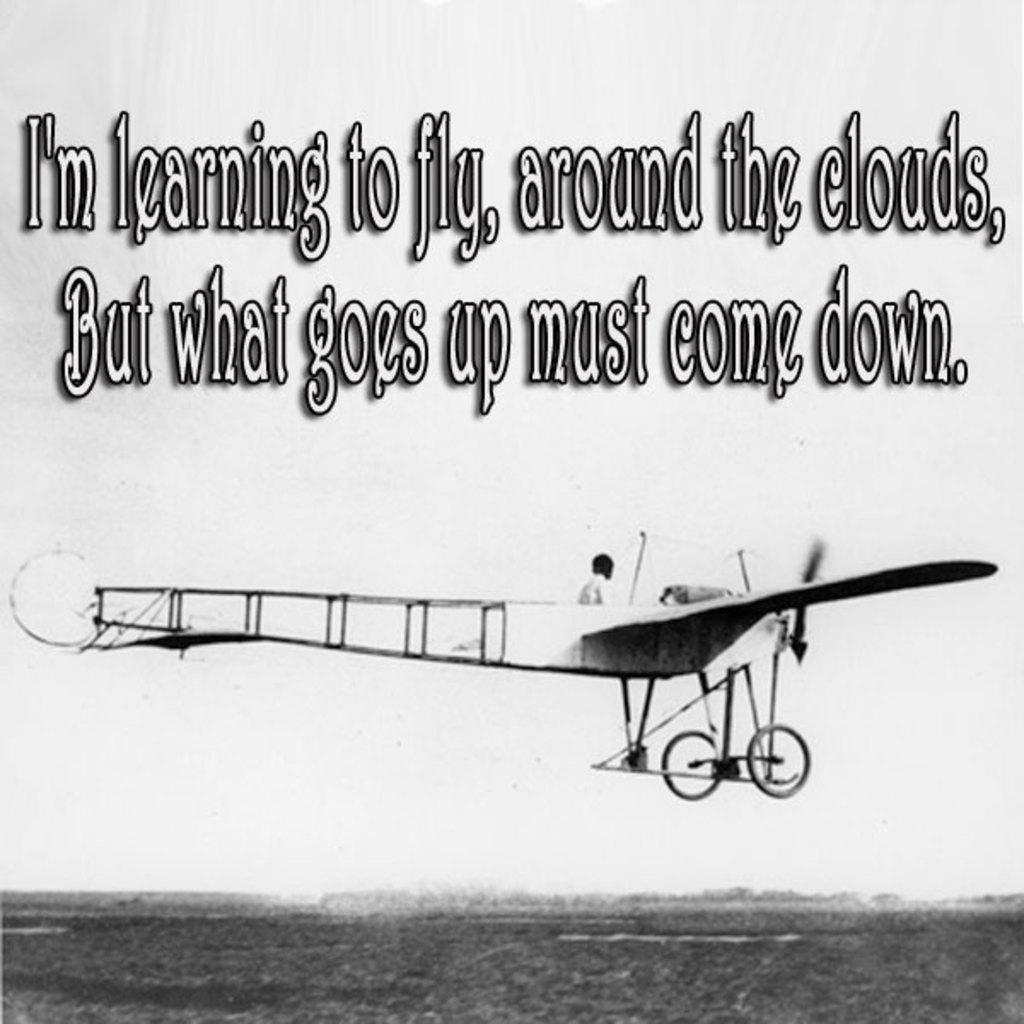What is the main subject of the image? The main subject of the image is an airplane. What can be seen inside the airplane? A man is sitting in the airplane. What item is visible at the top of the image? There is a coat visible at the top of the image. What type of thunder can be heard in the image? There is no thunder present in the image, as it is a still image and does not contain any sound. 